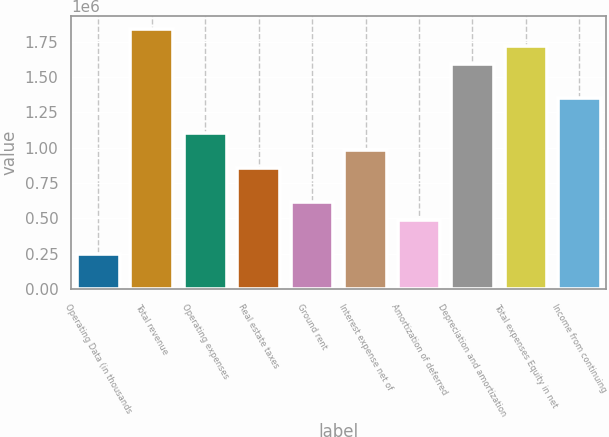<chart> <loc_0><loc_0><loc_500><loc_500><bar_chart><fcel>Operating Data (in thousands<fcel>Total revenue<fcel>Operating expenses<fcel>Real estate taxes<fcel>Ground rent<fcel>Interest expense net of<fcel>Amortization of deferred<fcel>Depreciation and amortization<fcel>Total expenses Equity in net<fcel>Income from continuing<nl><fcel>245481<fcel>1.84109e+06<fcel>1.10465e+06<fcel>859175<fcel>613697<fcel>981914<fcel>490958<fcel>1.59561e+06<fcel>1.71835e+06<fcel>1.35013e+06<nl></chart> 